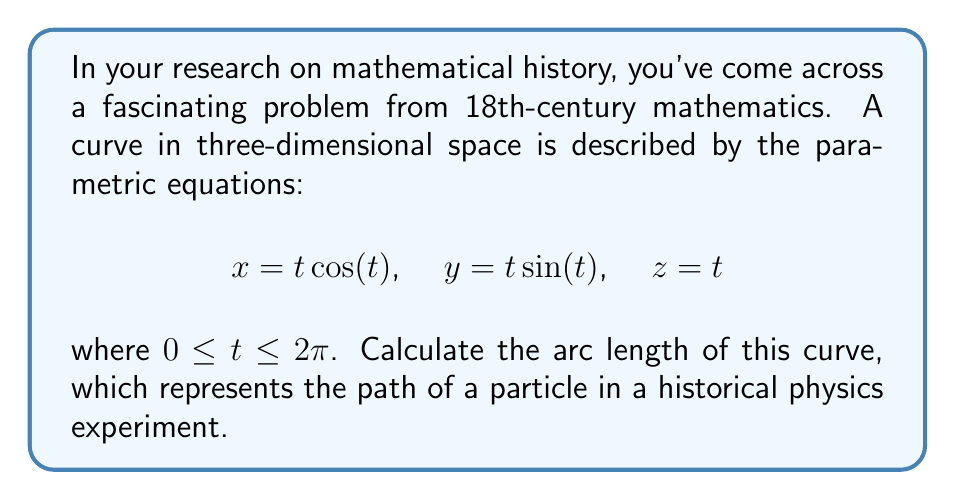Give your solution to this math problem. To find the arc length of a parametric curve in three-dimensional space, we use the formula:

$$L = \int_a^b \sqrt{\left(\frac{dx}{dt}\right)^2 + \left(\frac{dy}{dt}\right)^2 + \left(\frac{dz}{dt}\right)^2} dt$$

Step 1: Calculate the derivatives
$\frac{dx}{dt} = \cos(t) - t\sin(t)$
$\frac{dy}{dt} = \sin(t) + t\cos(t)$
$\frac{dz}{dt} = 1$

Step 2: Square each derivative
$\left(\frac{dx}{dt}\right)^2 = \cos^2(t) - 2t\cos(t)\sin(t) + t^2\sin^2(t)$
$\left(\frac{dy}{dt}\right)^2 = \sin^2(t) + 2t\cos(t)\sin(t) + t^2\cos^2(t)$
$\left(\frac{dz}{dt}\right)^2 = 1$

Step 3: Sum the squared derivatives
$$\left(\frac{dx}{dt}\right)^2 + \left(\frac{dy}{dt}\right)^2 + \left(\frac{dz}{dt}\right)^2 = \cos^2(t) + \sin^2(t) + t^2\cos^2(t) + t^2\sin^2(t) + 1$$

Step 4: Simplify
$\cos^2(t) + \sin^2(t) = 1$, and $t^2(\cos^2(t) + \sin^2(t)) = t^2$
So, the sum simplifies to $1 + t^2 + 1 = t^2 + 2$

Step 5: Take the square root
$\sqrt{t^2 + 2}$

Step 6: Set up the integral
$$L = \int_0^{2\pi} \sqrt{t^2 + 2} dt$$

Step 7: This integral doesn't have an elementary antiderivative, so we need to evaluate it numerically. Using a computer algebra system or numerical integration method, we can find that the value of this integral is approximately 14.7781.
Answer: $14.7781$ (rounded to 4 decimal places) 